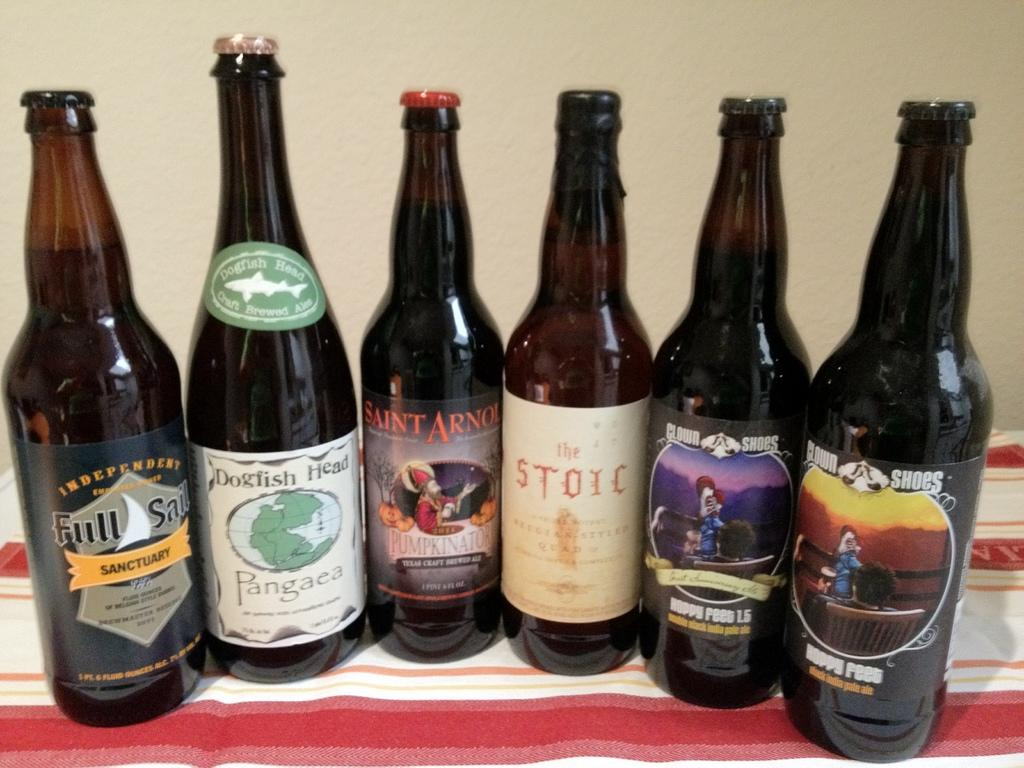What objects are present in the image? There are bottles in the image. What is the bottles placed on? The bottles are on a cloth. What can be seen in the background of the image? There is a wall visible in the background of the image. What type of fuel can be seen in the image? There is no fuel present in the image; it features bottles on a cloth with a wall in the background. Can you compare the height of the bottles to the height of the arch in the image? There is no arch present in the image, so it cannot be compared to the height of the bottles. 